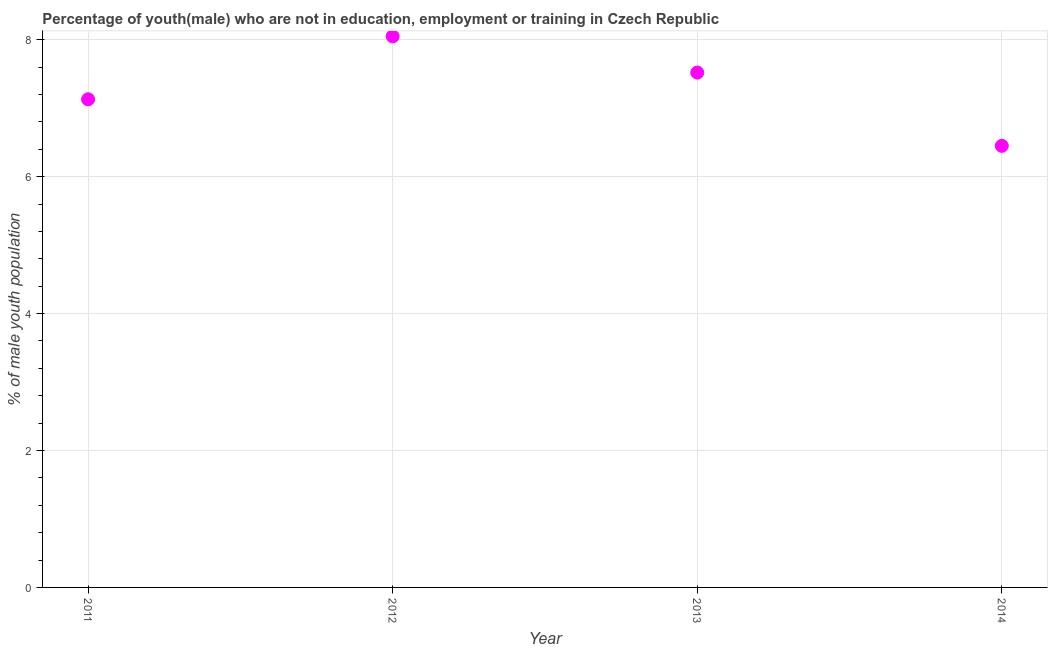What is the unemployed male youth population in 2013?
Provide a succinct answer. 7.52. Across all years, what is the maximum unemployed male youth population?
Your answer should be compact. 8.05. Across all years, what is the minimum unemployed male youth population?
Your answer should be compact. 6.45. What is the sum of the unemployed male youth population?
Give a very brief answer. 29.15. What is the difference between the unemployed male youth population in 2011 and 2012?
Provide a succinct answer. -0.92. What is the average unemployed male youth population per year?
Your answer should be very brief. 7.29. What is the median unemployed male youth population?
Ensure brevity in your answer.  7.33. In how many years, is the unemployed male youth population greater than 3.6 %?
Offer a terse response. 4. Do a majority of the years between 2011 and 2013 (inclusive) have unemployed male youth population greater than 2.8 %?
Give a very brief answer. Yes. What is the ratio of the unemployed male youth population in 2011 to that in 2012?
Keep it short and to the point. 0.89. Is the difference between the unemployed male youth population in 2012 and 2013 greater than the difference between any two years?
Provide a succinct answer. No. What is the difference between the highest and the second highest unemployed male youth population?
Offer a very short reply. 0.53. What is the difference between the highest and the lowest unemployed male youth population?
Keep it short and to the point. 1.6. In how many years, is the unemployed male youth population greater than the average unemployed male youth population taken over all years?
Your answer should be very brief. 2. Does the unemployed male youth population monotonically increase over the years?
Make the answer very short. No. How many years are there in the graph?
Your answer should be very brief. 4. What is the difference between two consecutive major ticks on the Y-axis?
Offer a terse response. 2. Does the graph contain any zero values?
Your answer should be compact. No. Does the graph contain grids?
Provide a short and direct response. Yes. What is the title of the graph?
Give a very brief answer. Percentage of youth(male) who are not in education, employment or training in Czech Republic. What is the label or title of the X-axis?
Offer a very short reply. Year. What is the label or title of the Y-axis?
Give a very brief answer. % of male youth population. What is the % of male youth population in 2011?
Offer a very short reply. 7.13. What is the % of male youth population in 2012?
Provide a short and direct response. 8.05. What is the % of male youth population in 2013?
Provide a succinct answer. 7.52. What is the % of male youth population in 2014?
Offer a very short reply. 6.45. What is the difference between the % of male youth population in 2011 and 2012?
Give a very brief answer. -0.92. What is the difference between the % of male youth population in 2011 and 2013?
Make the answer very short. -0.39. What is the difference between the % of male youth population in 2011 and 2014?
Ensure brevity in your answer.  0.68. What is the difference between the % of male youth population in 2012 and 2013?
Your answer should be very brief. 0.53. What is the difference between the % of male youth population in 2013 and 2014?
Your response must be concise. 1.07. What is the ratio of the % of male youth population in 2011 to that in 2012?
Provide a succinct answer. 0.89. What is the ratio of the % of male youth population in 2011 to that in 2013?
Keep it short and to the point. 0.95. What is the ratio of the % of male youth population in 2011 to that in 2014?
Give a very brief answer. 1.1. What is the ratio of the % of male youth population in 2012 to that in 2013?
Provide a short and direct response. 1.07. What is the ratio of the % of male youth population in 2012 to that in 2014?
Offer a terse response. 1.25. What is the ratio of the % of male youth population in 2013 to that in 2014?
Offer a very short reply. 1.17. 